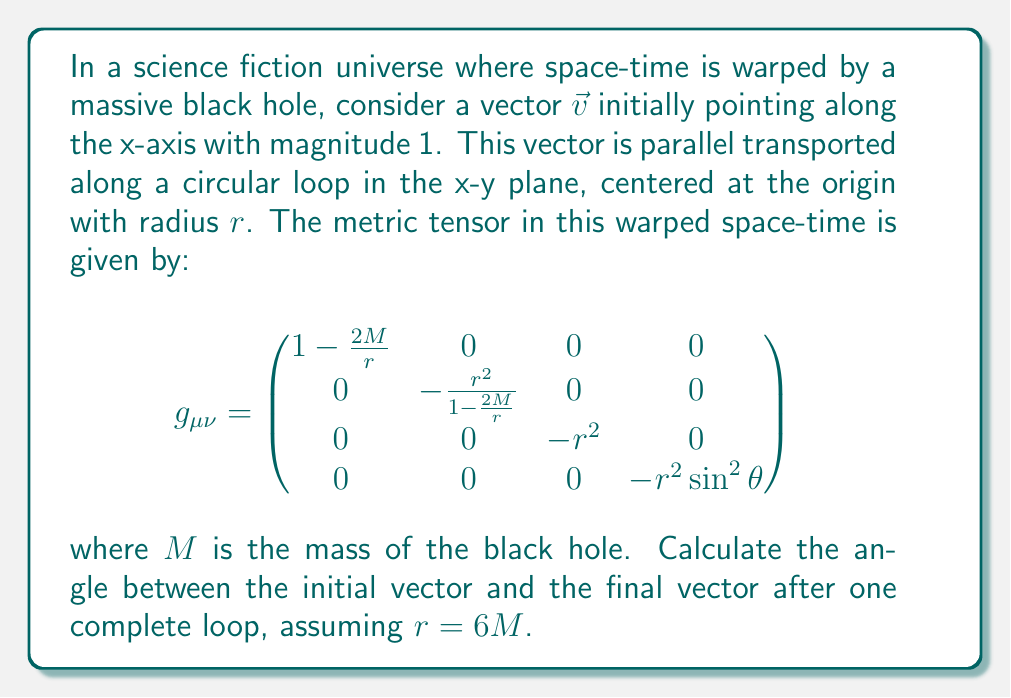Give your solution to this math problem. To solve this problem, we need to follow these steps:

1) First, we need to calculate the Christoffel symbols for this metric. The non-zero Christoffel symbols are:

   $$\Gamma^r_{tt} = \frac{M}{r^2}(1-\frac{2M}{r})$$
   $$\Gamma^t_{rt} = \Gamma^t_{tr} = \frac{M}{r^2(1-\frac{2M}{r})}$$
   $$\Gamma^r_{\phi\phi} = -r(1-\frac{2M}{r})$$
   $$\Gamma^\phi_{r\phi} = \Gamma^\phi_{\phi r} = \frac{1}{r}$$

2) The parallel transport equation is:

   $$\frac{dv^\mu}{d\lambda} + \Gamma^\mu_{\alpha\beta}v^\alpha\frac{dx^\beta}{d\lambda} = 0$$

3) For a circular loop in the x-y plane, we can parametrize the path as:
   
   $$x^\mu(\lambda) = (t, r\cos\lambda, r\sin\lambda, 0)$$

   where $\lambda$ goes from 0 to $2\pi$.

4) The only non-zero component of the initial vector is $v^x = 1$. Due to the symmetry of the problem, the $v^z$ component will remain zero throughout the transport.

5) Solving the parallel transport equations for $v^x$ and $v^y$:

   $$\frac{dv^x}{d\lambda} - rv^y = 0$$
   $$\frac{dv^y}{d\lambda} + rv^x = 0$$

6) These equations have the solution:

   $$v^x = \cos(r\lambda)$$
   $$v^y = \sin(r\lambda)$$

7) After one complete loop ($\lambda = 2\pi$), the final vector is:

   $$v^x = \cos(2\pi r)$$
   $$v^y = \sin(2\pi r)$$

8) The angle between the initial and final vector is $2\pi r$. 

9) Given $r = 6M$, the angle is $12\pi M$.

10) In Schwarzschild geometry, $M$ represents half the Schwarzschild radius. For $r = 6M$, we're at 3 times the Schwarzschild radius, which is a significant warping of space-time.

11) The final angle is thus $12\pi M = 2\pi$, or 360°.
Answer: 360° 